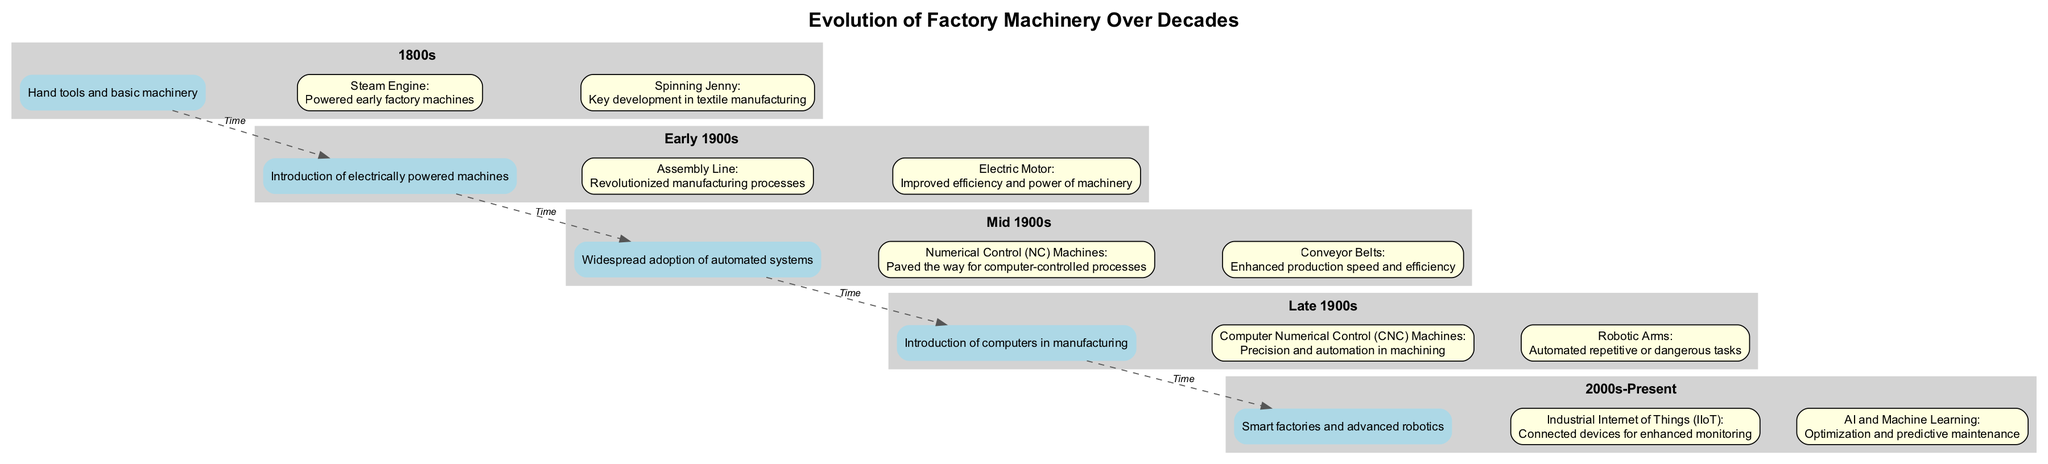What is the first key advancement in the 1800s? The diagram lists the first key advancement in the 1800s as the "Steam Engine," indicating its significance in powering early factory machines.
Answer: Steam Engine How many key advancements are shown for the Late 1900s? By analyzing the Late 1900s section of the diagram, two key advancements are identified: "Computer Numerical Control (CNC) Machines" and "Robotic Arms."
Answer: 2 What does the image labeled in the 2000s-Present section depict? The diagram shows an image labeled "modern_machinery.jpg," which corresponds to the era of smart factories and advanced robotics, indicating a significant evolution in factory machinery during this time.
Answer: modern_machinery.jpg Which advancement paved the way for computer-controlled processes? Referring to the Mid 1900s section of the diagram, "Numerical Control (NC) Machines" is highlighted as the advancement that paved the way for the development of computer-controlled processes.
Answer: Numerical Control (NC) Machines What connects the Early 1900s to the Mid 1900s? The diagram establishes a relationship labeled "Time" with a dashed edge connecting the Early 1900s era to the Mid 1900s era, indicating a chronological progression in the evolution of factory machinery.
Answer: Time Which advancement is associated with enhanced monitoring in the 2000s-Present? The diagram indicates that "Industrial Internet of Things (IIoT)" is the key advancement associated with enhanced monitoring in the 2000s-Present section.
Answer: Industrial Internet of Things (IIoT) How did the Assembly Line impact manufacturing processes? In the Early 1900s section, the "Assembly Line" is noted as a key advancement that revolutionized manufacturing processes, highlighting its transformative impact on how goods were produced.
Answer: Revolutionized manufacturing processes In which decade did the Conveyor Belts become widespread? The diagram categorizes Conveyor Belts as a key advancement in the Mid 1900s, indicating that this technology became widespread during this era.
Answer: Mid 1900s What are the two key advancements listed in the Late 1900s? The Late 1900s section features two key advancements: "Computer Numerical Control (CNC) Machines" and "Robotic Arms," highlighting advancements in precision and automation.
Answer: Computer Numerical Control (CNC) Machines and Robotic Arms 